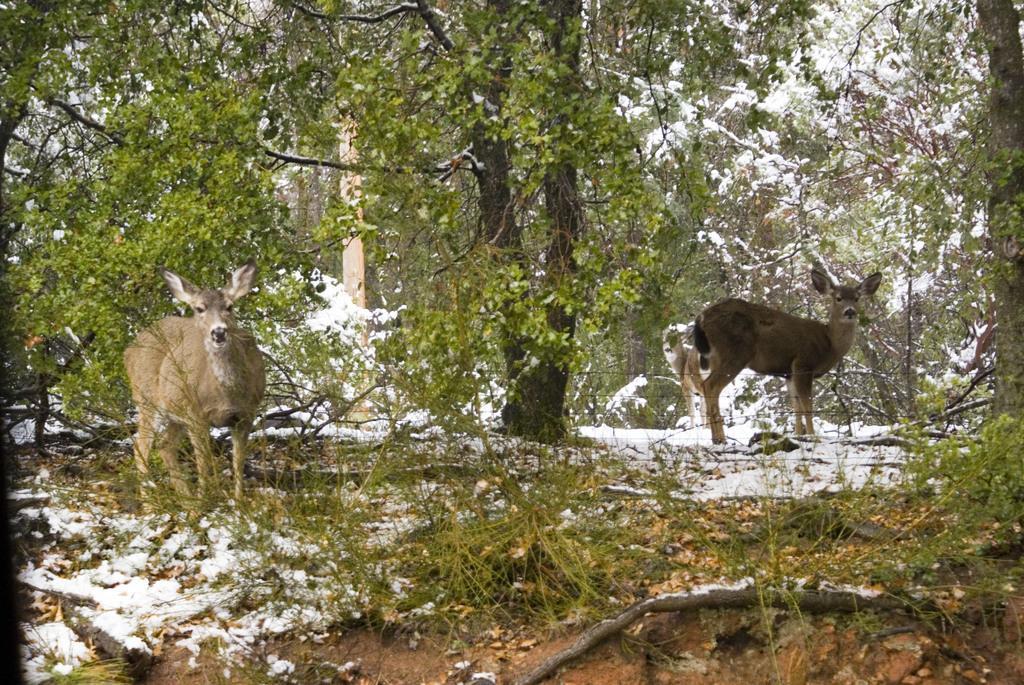How would you summarize this image in a sentence or two? In this image I can see there are two deers and there is the snow at the bottom, at the back side there are trees. 